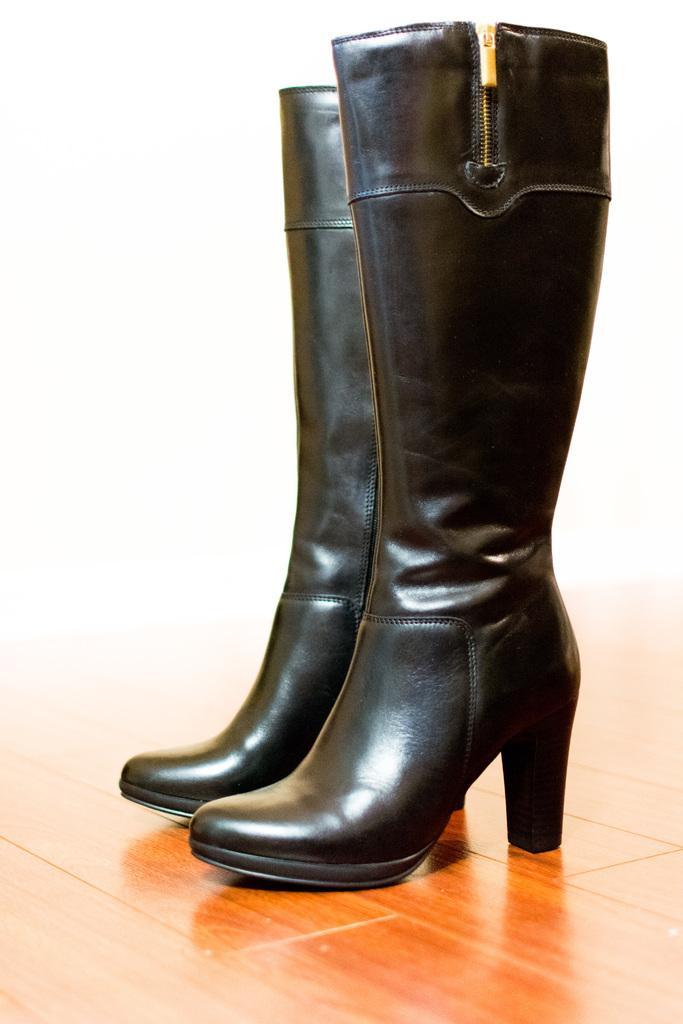In one or two sentences, can you explain what this image depicts? In this picture I can see the black color boots on the brown color surface and I see that it is white color in the background. 